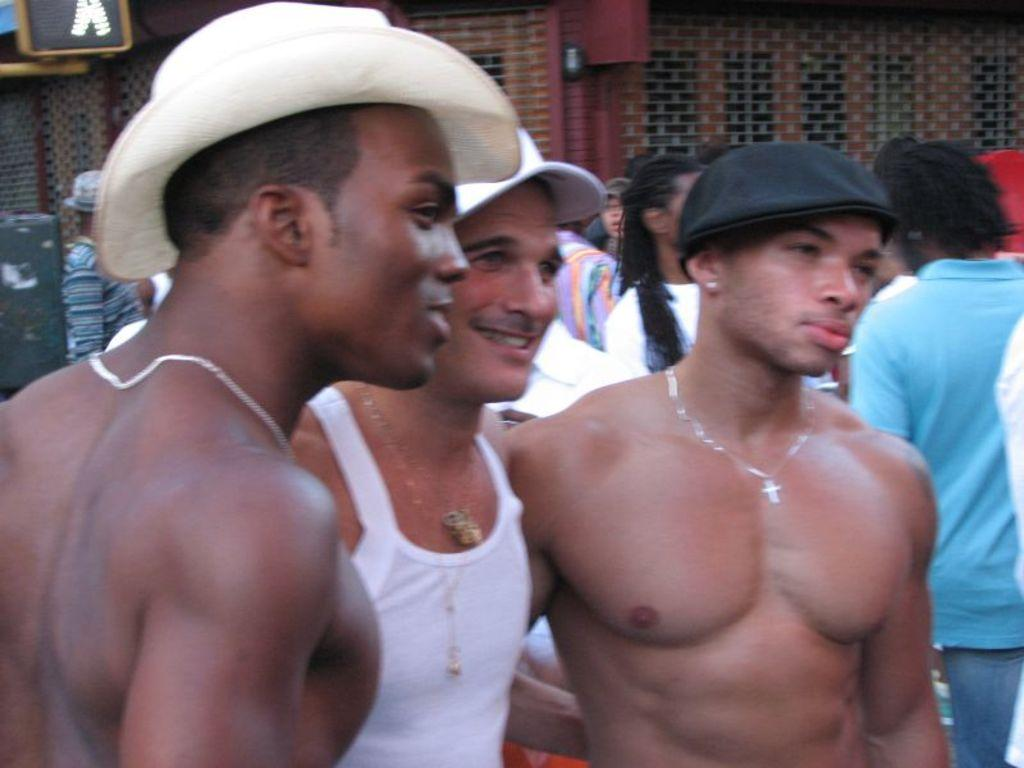How many men are in the foreground of the image? There are three men in the foreground of the image. What are the men wearing on their heads? The men are wearing hats. Can you describe the people in the background of the image? There are persons standing in the background of the image. What is visible at the top of the image? There is a wall visible in the top of the image. What type of lip can be seen on the wall in the image? There is no lip present on the wall in the image. How many houses are visible in the image? There is no mention of houses in the image; it features a wall and people. 